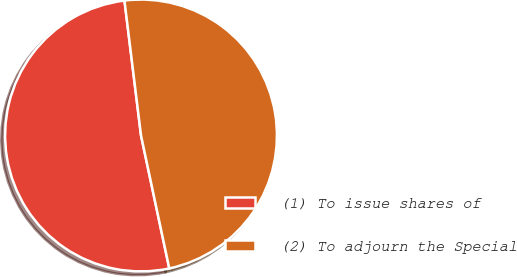<chart> <loc_0><loc_0><loc_500><loc_500><pie_chart><fcel>(1) To issue shares of<fcel>(2) To adjourn the Special<nl><fcel>51.39%<fcel>48.61%<nl></chart> 